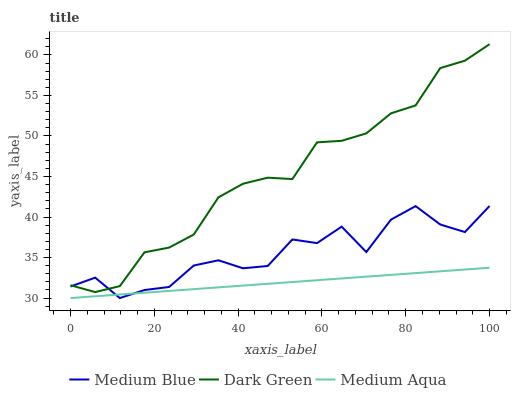Does Medium Aqua have the minimum area under the curve?
Answer yes or no. Yes. Does Dark Green have the maximum area under the curve?
Answer yes or no. Yes. Does Medium Blue have the minimum area under the curve?
Answer yes or no. No. Does Medium Blue have the maximum area under the curve?
Answer yes or no. No. Is Medium Aqua the smoothest?
Answer yes or no. Yes. Is Medium Blue the roughest?
Answer yes or no. Yes. Is Dark Green the smoothest?
Answer yes or no. No. Is Dark Green the roughest?
Answer yes or no. No. Does Medium Aqua have the lowest value?
Answer yes or no. Yes. Does Dark Green have the lowest value?
Answer yes or no. No. Does Dark Green have the highest value?
Answer yes or no. Yes. Does Medium Blue have the highest value?
Answer yes or no. No. Is Medium Aqua less than Dark Green?
Answer yes or no. Yes. Is Dark Green greater than Medium Aqua?
Answer yes or no. Yes. Does Medium Blue intersect Dark Green?
Answer yes or no. Yes. Is Medium Blue less than Dark Green?
Answer yes or no. No. Is Medium Blue greater than Dark Green?
Answer yes or no. No. Does Medium Aqua intersect Dark Green?
Answer yes or no. No. 